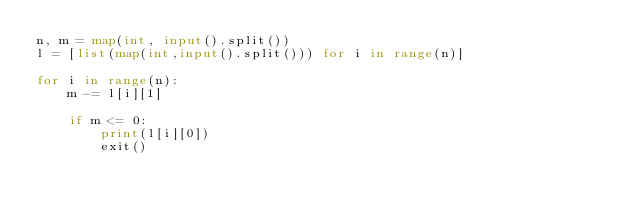Convert code to text. <code><loc_0><loc_0><loc_500><loc_500><_Python_>n, m = map(int, input().split())
l = [list(map(int,input().split())) for i in range(n)]

for i in range(n):
    m -= l[i][1]
    
    if m <= 0:
        print(l[i][0])
        exit()</code> 